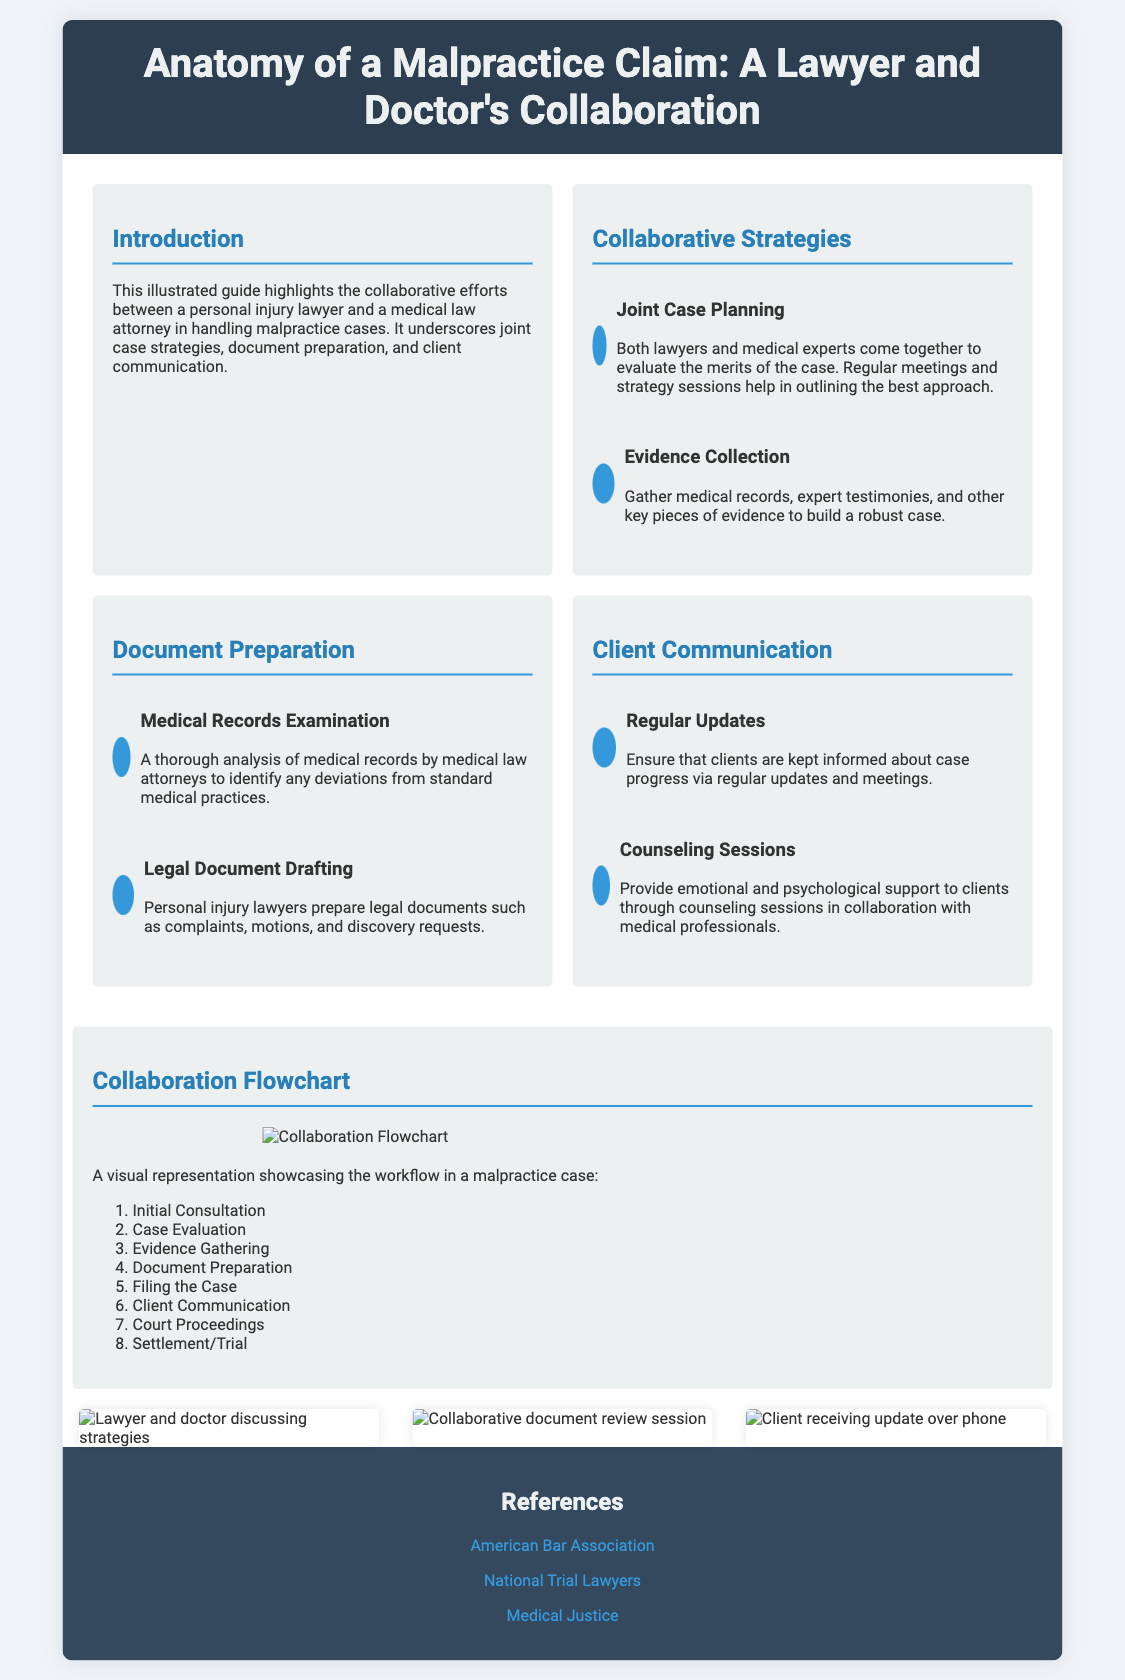what is the title of the poster? The title of the poster is prominently displayed at the top and is "Anatomy of a Malpractice Claim: A Lawyer and Doctor's Collaboration."
Answer: Anatomy of a Malpractice Claim: A Lawyer and Doctor's Collaboration how many sections are there in the content area? The content area contains four main sections: Collaborative Strategies, Document Preparation, Client Communication, and Collaboration Flowchart.
Answer: four what is the first step in the collaboration flowchart? The first step in the collaboration flowchart is listed as "Initial Consultation."
Answer: Initial Consultation which organization is referenced in the document? One of the references provided in the document is the "American Bar Association."
Answer: American Bar Association what type of support do counseling sessions provide? The counseling sessions are aimed at providing "emotional and psychological support" to clients.
Answer: emotional and psychological support how are medical records examined according to the poster? Medical records are examined through a "thorough analysis" by medical law attorneys.
Answer: thorough analysis what is one key component of joint case planning? A key component of joint case planning is "regular meetings and strategy sessions."
Answer: regular meetings and strategy sessions how many images are included in the document? The document includes three images showcasing different aspects of collaboration.
Answer: three 